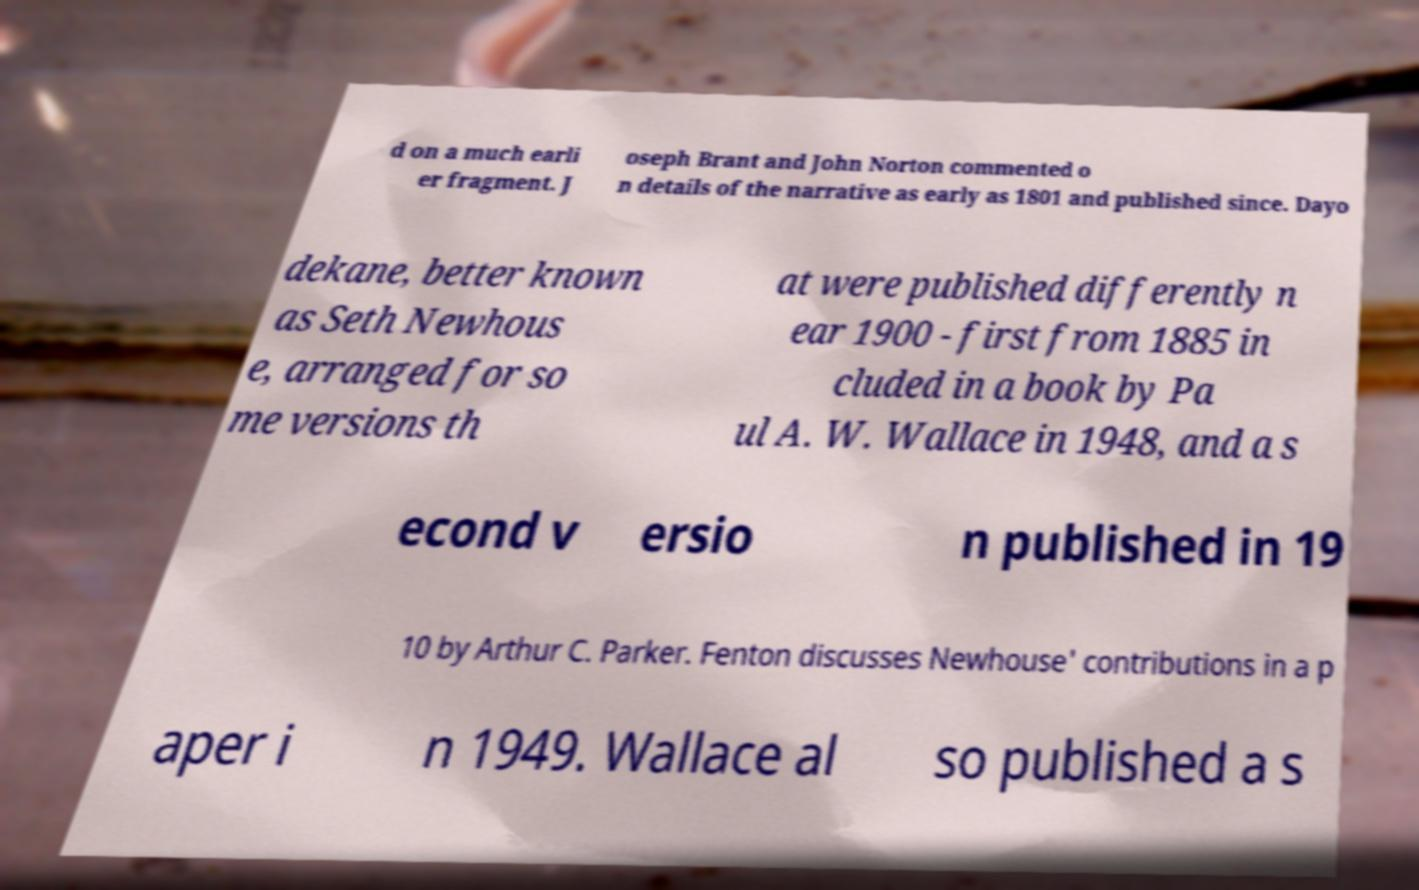Please read and relay the text visible in this image. What does it say? d on a much earli er fragment. J oseph Brant and John Norton commented o n details of the narrative as early as 1801 and published since. Dayo dekane, better known as Seth Newhous e, arranged for so me versions th at were published differently n ear 1900 - first from 1885 in cluded in a book by Pa ul A. W. Wallace in 1948, and a s econd v ersio n published in 19 10 by Arthur C. Parker. Fenton discusses Newhouse' contributions in a p aper i n 1949. Wallace al so published a s 